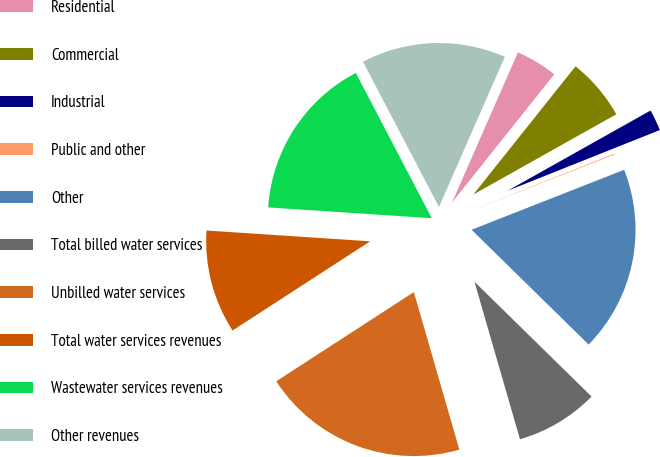Convert chart. <chart><loc_0><loc_0><loc_500><loc_500><pie_chart><fcel>Residential<fcel>Commercial<fcel>Industrial<fcel>Public and other<fcel>Other<fcel>Total billed water services<fcel>Unbilled water services<fcel>Total water services revenues<fcel>Wastewater services revenues<fcel>Other revenues<nl><fcel>4.13%<fcel>6.15%<fcel>2.1%<fcel>0.08%<fcel>18.3%<fcel>8.18%<fcel>20.32%<fcel>10.2%<fcel>16.28%<fcel>14.25%<nl></chart> 